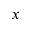<formula> <loc_0><loc_0><loc_500><loc_500>x</formula> 